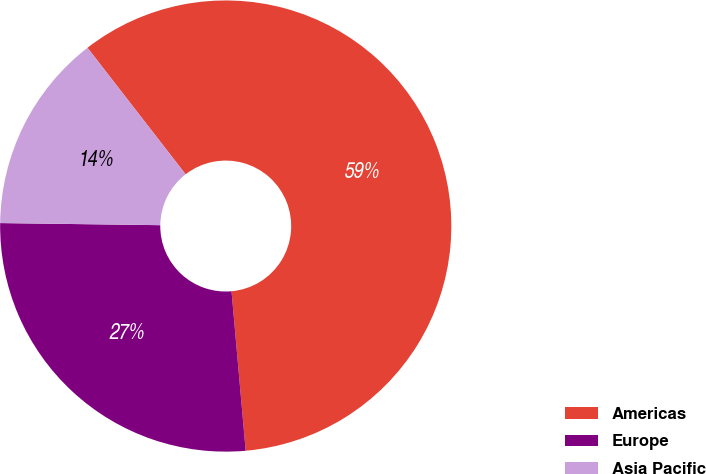<chart> <loc_0><loc_0><loc_500><loc_500><pie_chart><fcel>Americas<fcel>Europe<fcel>Asia Pacific<nl><fcel>59.09%<fcel>26.62%<fcel>14.29%<nl></chart> 